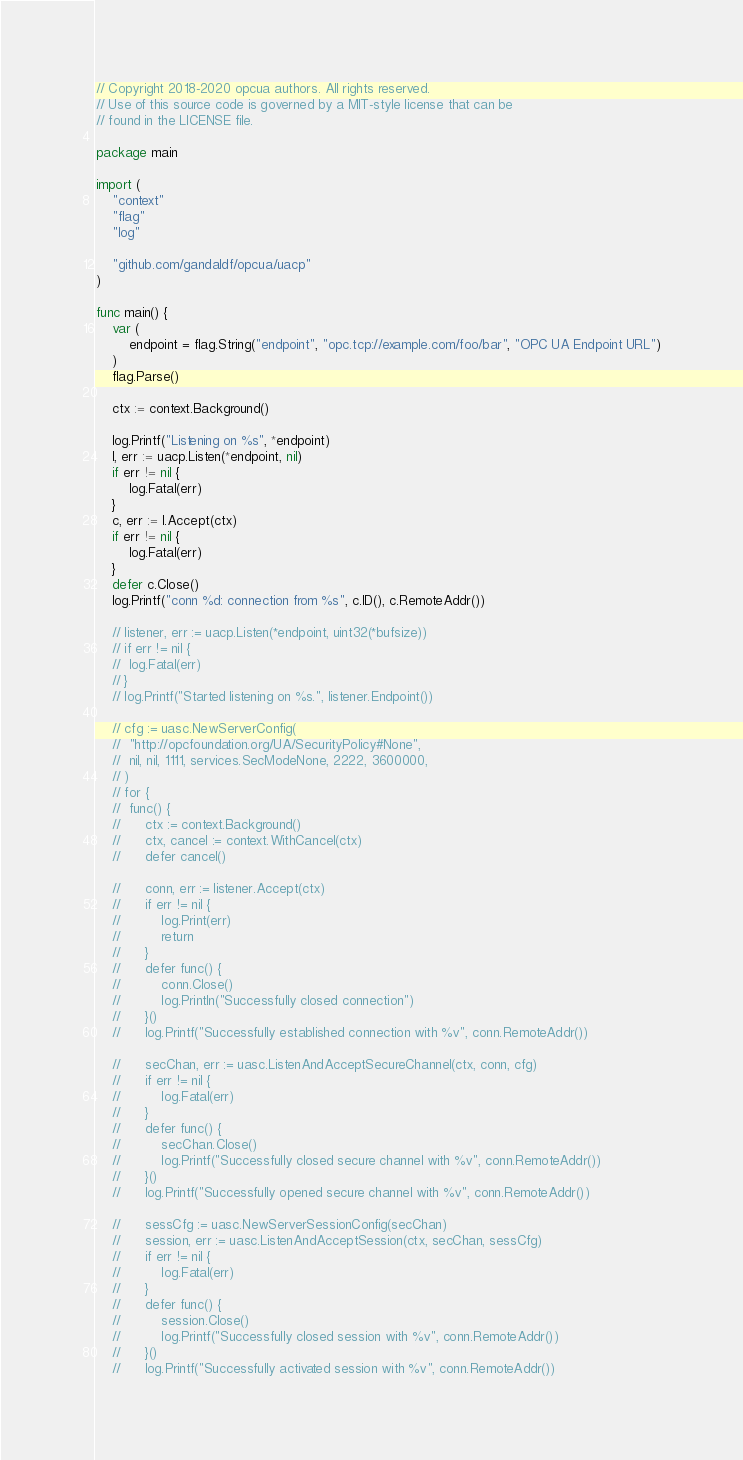Convert code to text. <code><loc_0><loc_0><loc_500><loc_500><_Go_>// Copyright 2018-2020 opcua authors. All rights reserved.
// Use of this source code is governed by a MIT-style license that can be
// found in the LICENSE file.

package main

import (
	"context"
	"flag"
	"log"

	"github.com/gandaldf/opcua/uacp"
)

func main() {
	var (
		endpoint = flag.String("endpoint", "opc.tcp://example.com/foo/bar", "OPC UA Endpoint URL")
	)
	flag.Parse()

	ctx := context.Background()

	log.Printf("Listening on %s", *endpoint)
	l, err := uacp.Listen(*endpoint, nil)
	if err != nil {
		log.Fatal(err)
	}
	c, err := l.Accept(ctx)
	if err != nil {
		log.Fatal(err)
	}
	defer c.Close()
	log.Printf("conn %d: connection from %s", c.ID(), c.RemoteAddr())

	// listener, err := uacp.Listen(*endpoint, uint32(*bufsize))
	// if err != nil {
	// 	log.Fatal(err)
	// }
	// log.Printf("Started listening on %s.", listener.Endpoint())

	// cfg := uasc.NewServerConfig(
	// 	"http://opcfoundation.org/UA/SecurityPolicy#None",
	// 	nil, nil, 1111, services.SecModeNone, 2222, 3600000,
	// )
	// for {
	// 	func() {
	// 		ctx := context.Background()
	// 		ctx, cancel := context.WithCancel(ctx)
	// 		defer cancel()

	// 		conn, err := listener.Accept(ctx)
	// 		if err != nil {
	// 			log.Print(err)
	// 			return
	// 		}
	// 		defer func() {
	// 			conn.Close()
	// 			log.Println("Successfully closed connection")
	// 		}()
	// 		log.Printf("Successfully established connection with %v", conn.RemoteAddr())

	// 		secChan, err := uasc.ListenAndAcceptSecureChannel(ctx, conn, cfg)
	// 		if err != nil {
	// 			log.Fatal(err)
	// 		}
	// 		defer func() {
	// 			secChan.Close()
	// 			log.Printf("Successfully closed secure channel with %v", conn.RemoteAddr())
	// 		}()
	// 		log.Printf("Successfully opened secure channel with %v", conn.RemoteAddr())

	// 		sessCfg := uasc.NewServerSessionConfig(secChan)
	// 		session, err := uasc.ListenAndAcceptSession(ctx, secChan, sessCfg)
	// 		if err != nil {
	// 			log.Fatal(err)
	// 		}
	// 		defer func() {
	// 			session.Close()
	// 			log.Printf("Successfully closed session with %v", conn.RemoteAddr())
	// 		}()
	// 		log.Printf("Successfully activated session with %v", conn.RemoteAddr())
</code> 